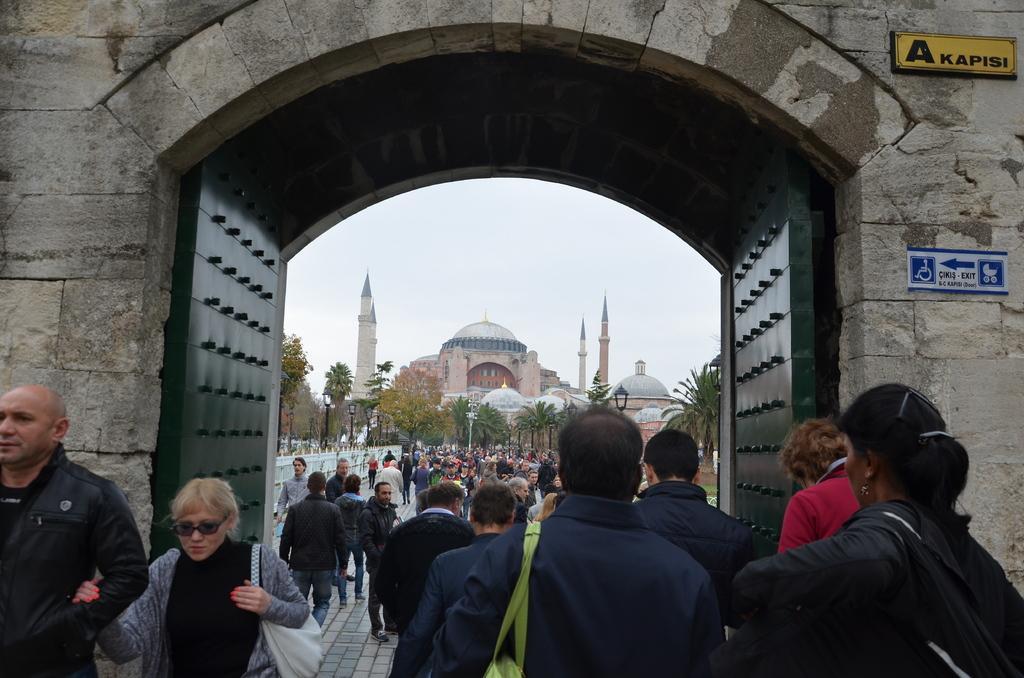How would you summarize this image in a sentence or two? In this image I can see group of people. In the background trees, poles, a building and the sky. Here I can see gates and a wall which has some boards attached to it. 